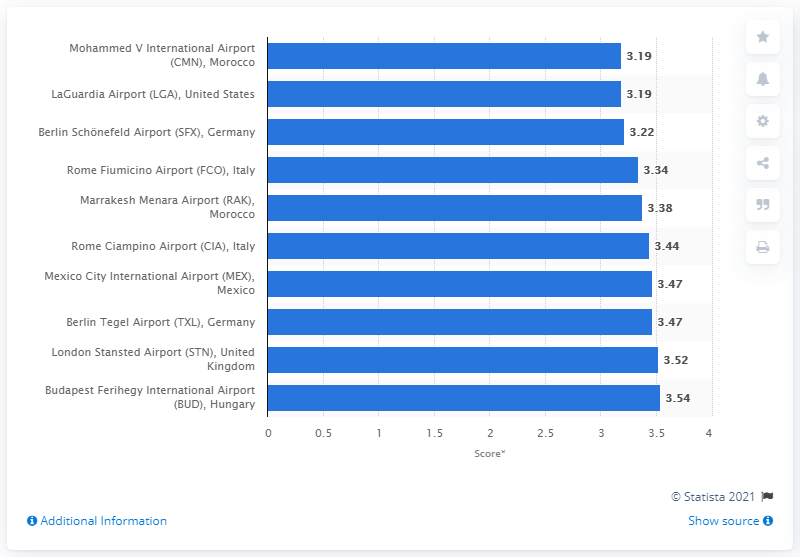Give some essential details in this illustration. The Mohammed V International Airport received a score of 3.19 out of five in 2015. 